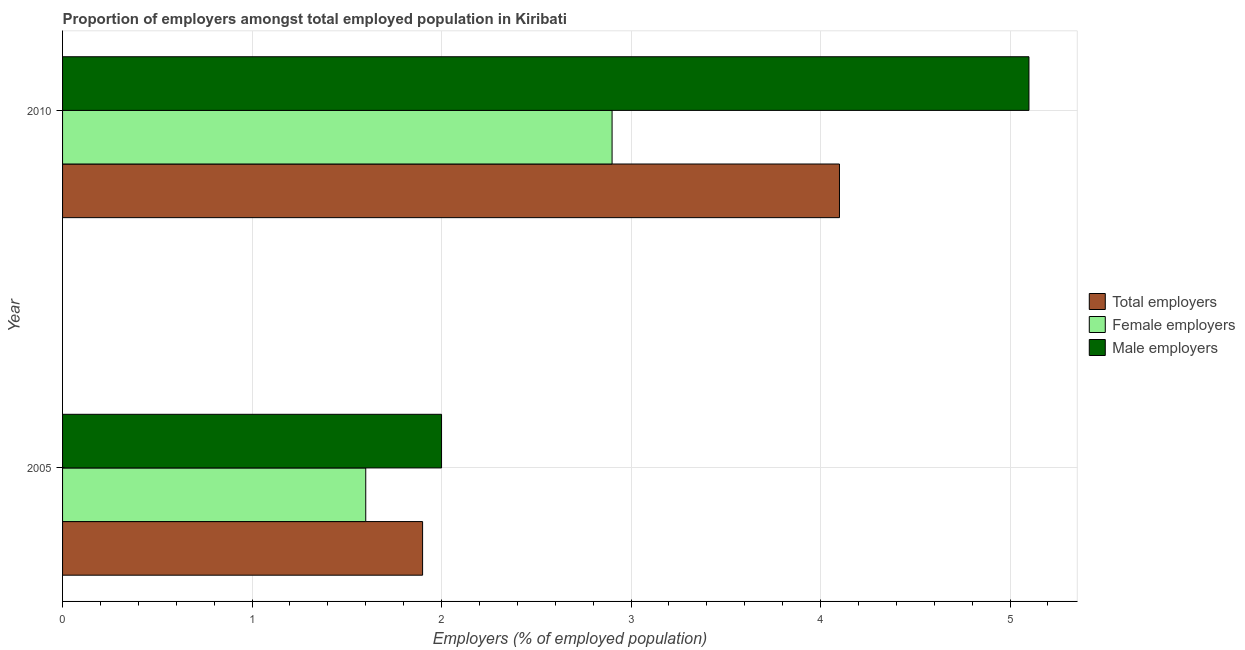How many bars are there on the 1st tick from the top?
Give a very brief answer. 3. In how many cases, is the number of bars for a given year not equal to the number of legend labels?
Give a very brief answer. 0. What is the percentage of total employers in 2010?
Make the answer very short. 4.1. Across all years, what is the maximum percentage of male employers?
Offer a terse response. 5.1. Across all years, what is the minimum percentage of male employers?
Give a very brief answer. 2. What is the total percentage of male employers in the graph?
Ensure brevity in your answer.  7.1. What is the difference between the percentage of female employers in 2010 and the percentage of male employers in 2005?
Your response must be concise. 0.9. In how many years, is the percentage of total employers greater than 1.8 %?
Provide a succinct answer. 2. What is the ratio of the percentage of female employers in 2005 to that in 2010?
Provide a succinct answer. 0.55. In how many years, is the percentage of total employers greater than the average percentage of total employers taken over all years?
Offer a terse response. 1. What does the 1st bar from the top in 2005 represents?
Your answer should be compact. Male employers. What does the 1st bar from the bottom in 2005 represents?
Your answer should be very brief. Total employers. Are all the bars in the graph horizontal?
Provide a short and direct response. Yes. How many years are there in the graph?
Your answer should be very brief. 2. What is the difference between two consecutive major ticks on the X-axis?
Offer a terse response. 1. Are the values on the major ticks of X-axis written in scientific E-notation?
Make the answer very short. No. Does the graph contain grids?
Give a very brief answer. Yes. How many legend labels are there?
Give a very brief answer. 3. How are the legend labels stacked?
Keep it short and to the point. Vertical. What is the title of the graph?
Offer a terse response. Proportion of employers amongst total employed population in Kiribati. What is the label or title of the X-axis?
Make the answer very short. Employers (% of employed population). What is the Employers (% of employed population) of Total employers in 2005?
Ensure brevity in your answer.  1.9. What is the Employers (% of employed population) in Female employers in 2005?
Provide a short and direct response. 1.6. What is the Employers (% of employed population) in Total employers in 2010?
Offer a terse response. 4.1. What is the Employers (% of employed population) of Female employers in 2010?
Give a very brief answer. 2.9. What is the Employers (% of employed population) in Male employers in 2010?
Give a very brief answer. 5.1. Across all years, what is the maximum Employers (% of employed population) of Total employers?
Keep it short and to the point. 4.1. Across all years, what is the maximum Employers (% of employed population) of Female employers?
Keep it short and to the point. 2.9. Across all years, what is the maximum Employers (% of employed population) of Male employers?
Your answer should be compact. 5.1. Across all years, what is the minimum Employers (% of employed population) in Total employers?
Ensure brevity in your answer.  1.9. Across all years, what is the minimum Employers (% of employed population) of Female employers?
Ensure brevity in your answer.  1.6. What is the total Employers (% of employed population) of Total employers in the graph?
Provide a short and direct response. 6. What is the total Employers (% of employed population) of Male employers in the graph?
Offer a terse response. 7.1. What is the difference between the Employers (% of employed population) in Total employers in 2005 and that in 2010?
Offer a very short reply. -2.2. What is the difference between the Employers (% of employed population) in Male employers in 2005 and that in 2010?
Your response must be concise. -3.1. What is the difference between the Employers (% of employed population) in Female employers in 2005 and the Employers (% of employed population) in Male employers in 2010?
Give a very brief answer. -3.5. What is the average Employers (% of employed population) in Female employers per year?
Offer a very short reply. 2.25. What is the average Employers (% of employed population) in Male employers per year?
Offer a very short reply. 3.55. In the year 2005, what is the difference between the Employers (% of employed population) in Female employers and Employers (% of employed population) in Male employers?
Your answer should be compact. -0.4. What is the ratio of the Employers (% of employed population) of Total employers in 2005 to that in 2010?
Ensure brevity in your answer.  0.46. What is the ratio of the Employers (% of employed population) of Female employers in 2005 to that in 2010?
Ensure brevity in your answer.  0.55. What is the ratio of the Employers (% of employed population) of Male employers in 2005 to that in 2010?
Make the answer very short. 0.39. What is the difference between the highest and the second highest Employers (% of employed population) of Total employers?
Offer a very short reply. 2.2. What is the difference between the highest and the lowest Employers (% of employed population) of Total employers?
Your answer should be compact. 2.2. What is the difference between the highest and the lowest Employers (% of employed population) of Female employers?
Provide a short and direct response. 1.3. What is the difference between the highest and the lowest Employers (% of employed population) in Male employers?
Provide a succinct answer. 3.1. 